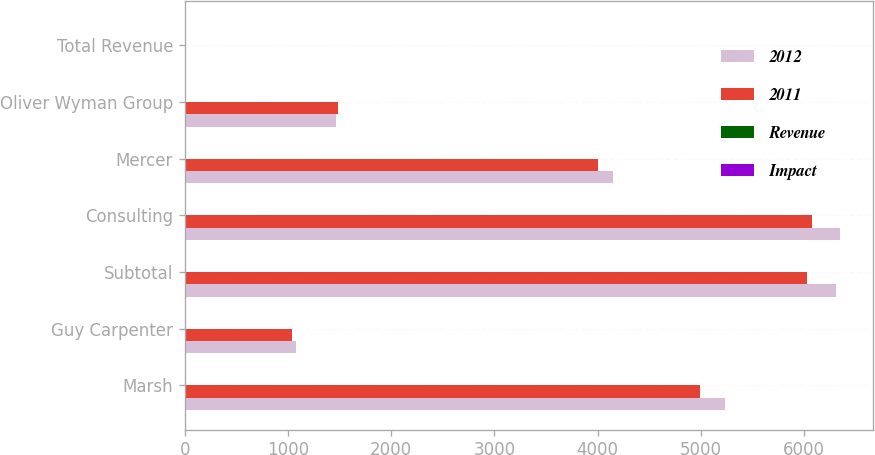<chart> <loc_0><loc_0><loc_500><loc_500><stacked_bar_chart><ecel><fcel>Marsh<fcel>Guy Carpenter<fcel>Subtotal<fcel>Consulting<fcel>Mercer<fcel>Oliver Wyman Group<fcel>Total Revenue<nl><fcel>2012<fcel>5232<fcel>1079<fcel>6311<fcel>6350<fcel>4147<fcel>1466<fcel>5<nl><fcel>2011<fcel>4991<fcel>1041<fcel>6032<fcel>6079<fcel>4004<fcel>1483<fcel>5<nl><fcel>Revenue<fcel>5<fcel>4<fcel>5<fcel>4<fcel>4<fcel>1<fcel>3<nl><fcel>Impact<fcel>2<fcel>1<fcel>2<fcel>2<fcel>1<fcel>2<fcel>2<nl></chart> 